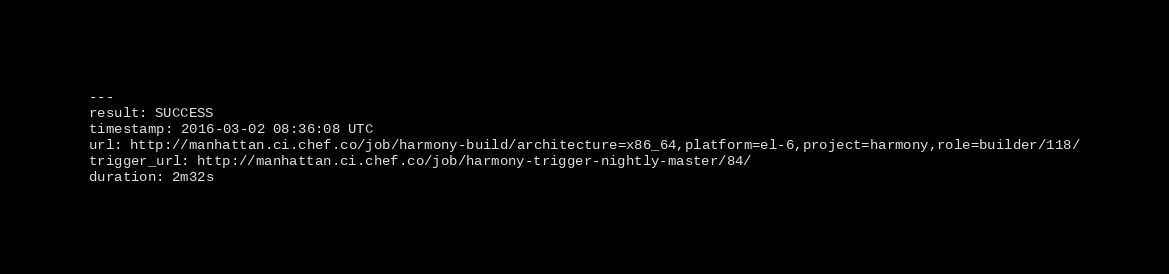Convert code to text. <code><loc_0><loc_0><loc_500><loc_500><_YAML_>---
result: SUCCESS
timestamp: 2016-03-02 08:36:08 UTC
url: http://manhattan.ci.chef.co/job/harmony-build/architecture=x86_64,platform=el-6,project=harmony,role=builder/118/
trigger_url: http://manhattan.ci.chef.co/job/harmony-trigger-nightly-master/84/
duration: 2m32s
</code> 